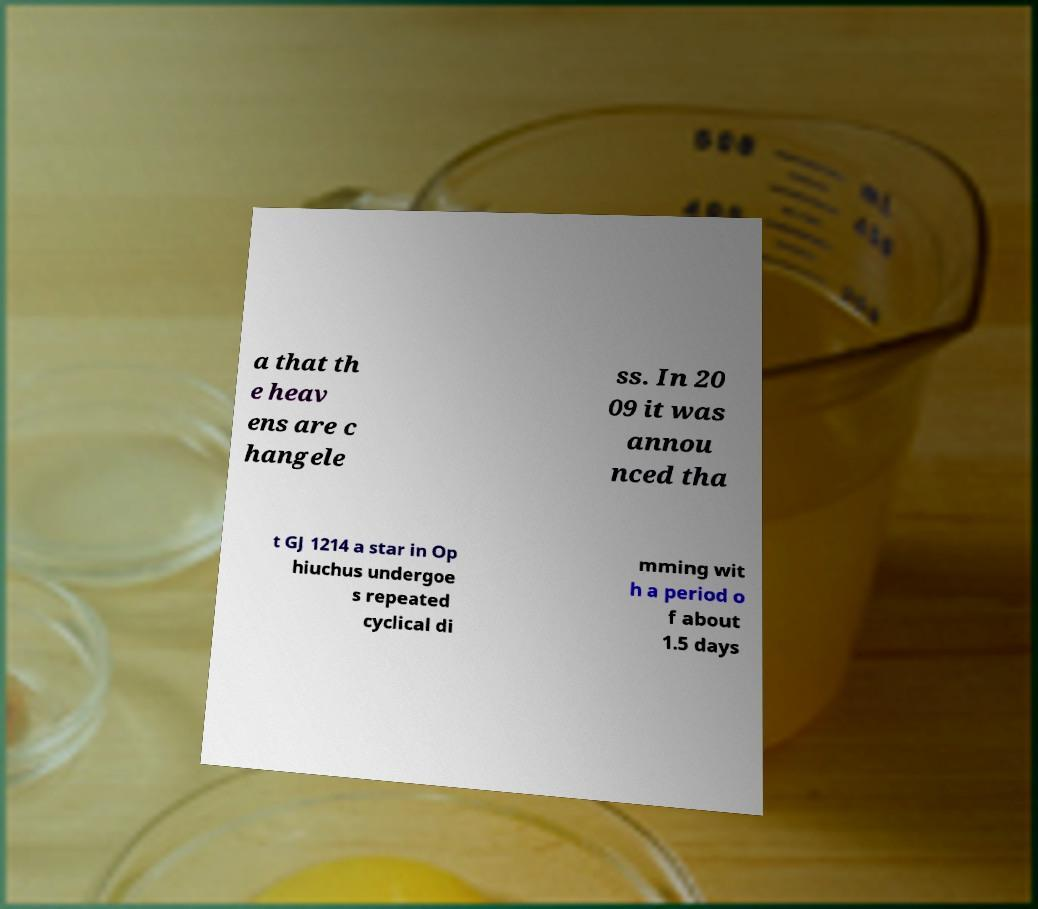What messages or text are displayed in this image? I need them in a readable, typed format. a that th e heav ens are c hangele ss. In 20 09 it was annou nced tha t GJ 1214 a star in Op hiuchus undergoe s repeated cyclical di mming wit h a period o f about 1.5 days 